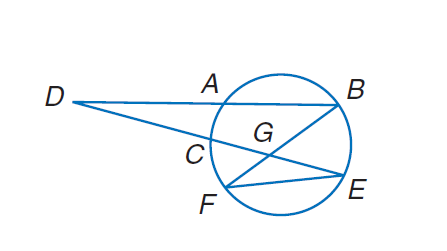Answer the mathemtical geometry problem and directly provide the correct option letter.
Question: If m \widehat F E = 118, m \widehat A B = 108, m \angle E G B = 52, and m \angle E F B = 30. Find m \widehat A C.
Choices: A: 30 B: 52 C: 108 D: 118 A 